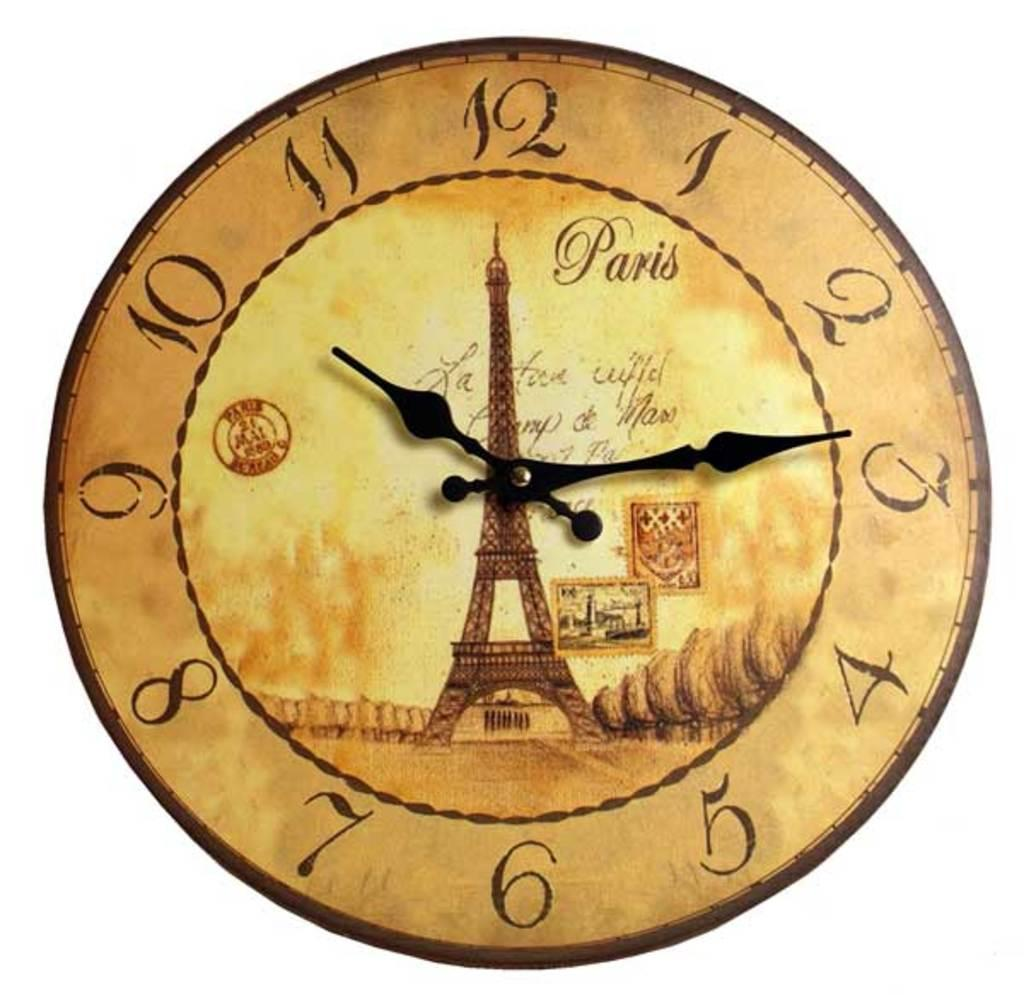<image>
Render a clear and concise summary of the photo. the name Paris is on the front of a clock 